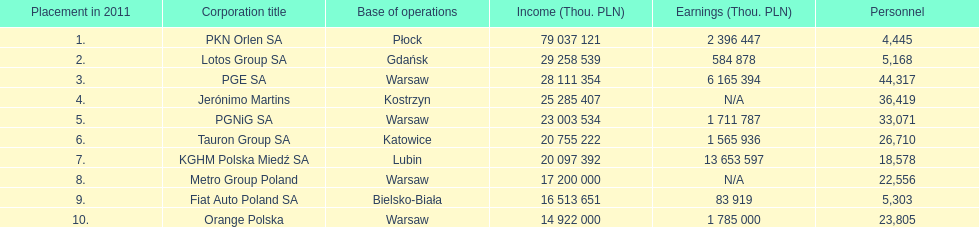How many companies had over $1,000,000 profit? 6. 